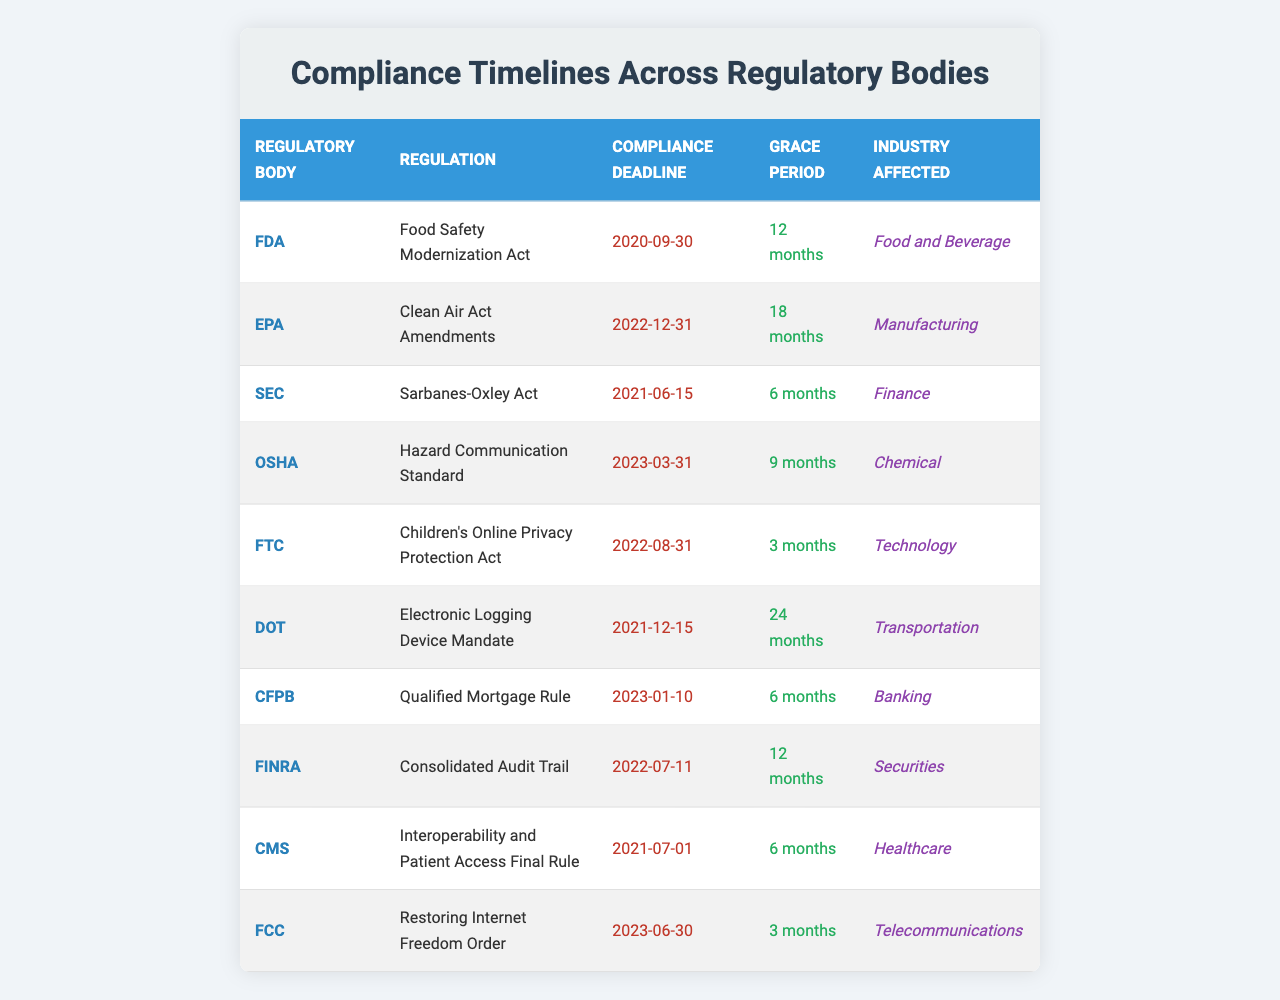What is the compliance deadline for the Clean Air Act Amendments? The table lists the compliance deadlines for various regulations. For the Clean Air Act Amendments under the EPA, the compliance deadline is specifically mentioned as December 31, 2022.
Answer: December 31, 2022 How many months of grace period does the Hazard Communication Standard have? Looking at the OSHA row in the table, the grace period for the Hazard Communication Standard is provided, which is noted as 9 months.
Answer: 9 months Which regulatory body has the longest grace period, and what is the duration? By examining the grace periods listed in the table, the DOT (Department of Transportation) has the longest grace period of 24 months for the Electronic Logging Device Mandate.
Answer: DOT, 24 months Is the compliance deadline for the Children's Online Privacy Protection Act before or after September 30, 2020? The table shows that the compliance deadline for the Children’s Online Privacy Protection Act, set by the FTC, is August 31, 2022. Comparing this with September 30, 2020, it is clear that August 31, 2022, is after September 30, 2020.
Answer: After What is the average grace period across all regulatory bodies listed in the table? The grace periods listed in the table are 12 months, 18 months, 6 months, 9 months, 3 months, 24 months, 6 months, 12 months, 6 months, and 3 months. To find the average, sum these values (12 + 18 + 6 + 9 + 3 + 24 + 6 + 12 + 6 + 3 = 99) and divide by the total number of grace periods (10). Thus, 99/10 = 9.9 months is the average grace period.
Answer: 9.9 months What industries are affected by the regulations with the latest compliance deadlines? Referring to the table, the latest compliance deadlines are for the Hazard Communication Standard (March 31, 2023) and the Restoring Internet Freedom Order (June 30, 2023). The industries affected are Chemical for OSHA and Telecommunications for FCC. Thus, both industries are affected by the regulations with the latest compliance deadlines.
Answer: Chemical and Telecommunications Which regulatory body follows the Sarbanes-Oxley Act in terms of the compliance deadline, and what is the regulation associated with it? The Sarbanes-Oxley Act has a compliance deadline of June 15, 2021. The next compliance deadline listed in the table is December 15, 2021, for the Electronic Logging Device Mandate from the DOT. Therefore, the DOT follows the SEC in terms of compliance deadlines.
Answer: DOT, Electronic Logging Device Mandate For the Healthcare industry, what is the compliance deadline and grace period? Looking at the Healthcare industry row in the table, the relevant regulation is the Interoperability and Patient Access Final Rule, which has a compliance deadline of July 1, 2021, and a grace period of 6 months.
Answer: July 1, 2021, and 6 months Is there a regulatory body that has a compliance deadline in 2023, and if so, which one? Scanning the table, the two regulatory bodies with compliance deadlines in 2023 are OSHA (March 31, 2023) and FCC (June 30, 2023). Thus, there are regulatory bodies with compliance deadlines in 2023.
Answer: Yes, OSHA and FCC What is the earliest compliance deadline recorded in the table? The compliance deadlines in the table are compared, and it is found that the earliest date is September 30, 2020, for the Food Safety Modernization Act by the FDA.
Answer: September 30, 2020 How many different regulatory bodies are represented in the table? Counting each unique regulatory body listed in the table yields a total of 10 different regulatory bodies: FDA, EPA, SEC, OSHA, FTC, DOT, CFPB, FINRA, CMS, and FCC. Therefore, the answer to the question is 10.
Answer: 10 